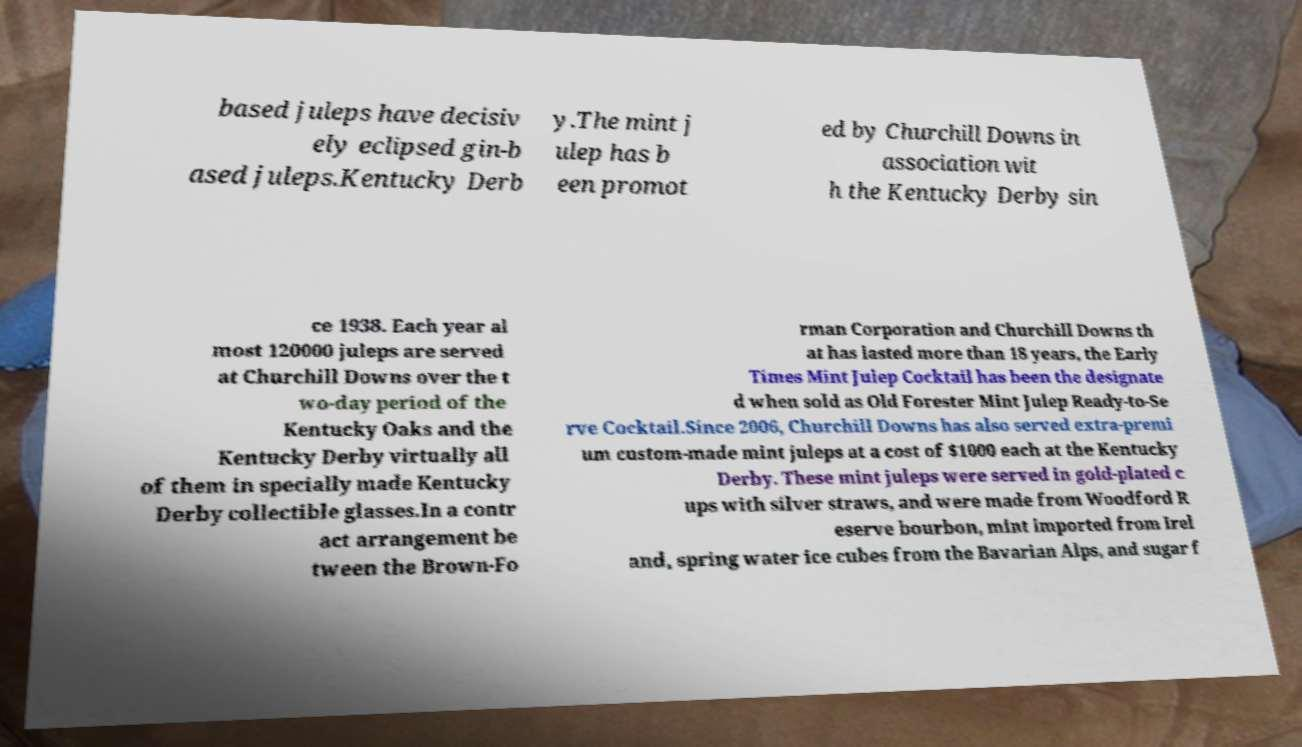I need the written content from this picture converted into text. Can you do that? based juleps have decisiv ely eclipsed gin-b ased juleps.Kentucky Derb y.The mint j ulep has b een promot ed by Churchill Downs in association wit h the Kentucky Derby sin ce 1938. Each year al most 120000 juleps are served at Churchill Downs over the t wo-day period of the Kentucky Oaks and the Kentucky Derby virtually all of them in specially made Kentucky Derby collectible glasses.In a contr act arrangement be tween the Brown-Fo rman Corporation and Churchill Downs th at has lasted more than 18 years, the Early Times Mint Julep Cocktail has been the designate d when sold as Old Forester Mint Julep Ready-to-Se rve Cocktail.Since 2006, Churchill Downs has also served extra-premi um custom-made mint juleps at a cost of $1000 each at the Kentucky Derby. These mint juleps were served in gold-plated c ups with silver straws, and were made from Woodford R eserve bourbon, mint imported from Irel and, spring water ice cubes from the Bavarian Alps, and sugar f 